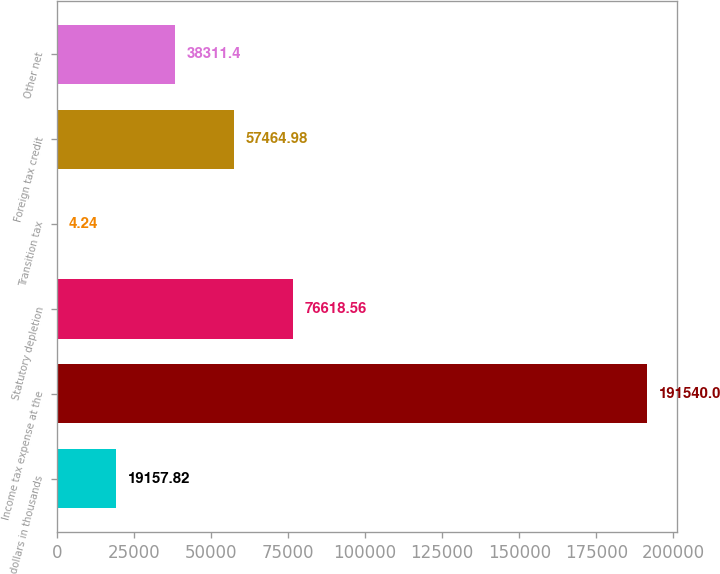<chart> <loc_0><loc_0><loc_500><loc_500><bar_chart><fcel>dollars in thousands<fcel>Income tax expense at the<fcel>Statutory depletion<fcel>Transition tax<fcel>Foreign tax credit<fcel>Other net<nl><fcel>19157.8<fcel>191540<fcel>76618.6<fcel>4.24<fcel>57465<fcel>38311.4<nl></chart> 